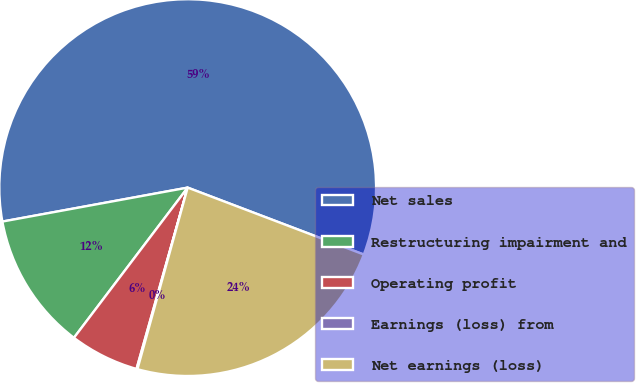<chart> <loc_0><loc_0><loc_500><loc_500><pie_chart><fcel>Net sales<fcel>Restructuring impairment and<fcel>Operating profit<fcel>Earnings (loss) from<fcel>Net earnings (loss)<nl><fcel>58.67%<fcel>11.8%<fcel>5.94%<fcel>0.08%<fcel>23.52%<nl></chart> 